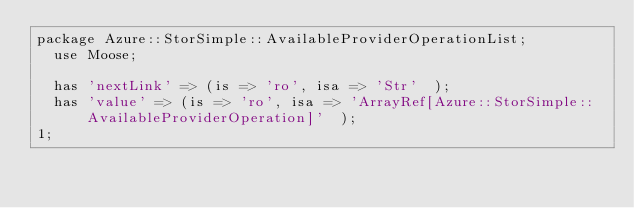Convert code to text. <code><loc_0><loc_0><loc_500><loc_500><_Perl_>package Azure::StorSimple::AvailableProviderOperationList;
  use Moose;

  has 'nextLink' => (is => 'ro', isa => 'Str'  );
  has 'value' => (is => 'ro', isa => 'ArrayRef[Azure::StorSimple::AvailableProviderOperation]'  );
1;
</code> 